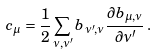Convert formula to latex. <formula><loc_0><loc_0><loc_500><loc_500>c _ { \mu } = \frac { 1 } { 2 } \sum _ { \nu , \nu ^ { \prime } } b _ { \nu ^ { \prime } , \nu } \frac { \partial b _ { \mu , \nu } } { \partial \nu ^ { \prime } } \, .</formula> 